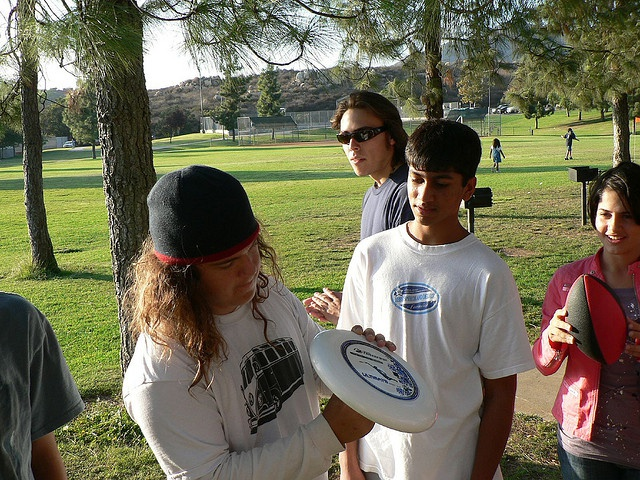Describe the objects in this image and their specific colors. I can see people in white, gray, black, and maroon tones, people in white, gray, black, and darkgray tones, people in white, black, maroon, and gray tones, people in white, black, gray, and maroon tones, and people in white, black, maroon, lightgray, and brown tones in this image. 